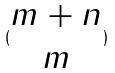Convert formula to latex. <formula><loc_0><loc_0><loc_500><loc_500>( \begin{matrix} m + n \\ m \end{matrix} )</formula> 